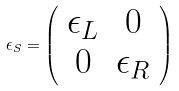Convert formula to latex. <formula><loc_0><loc_0><loc_500><loc_500>\epsilon _ { S } = \left ( \begin{array} { c c } \epsilon _ { L } & 0 \\ 0 & \epsilon _ { R } \end{array} \right )</formula> 